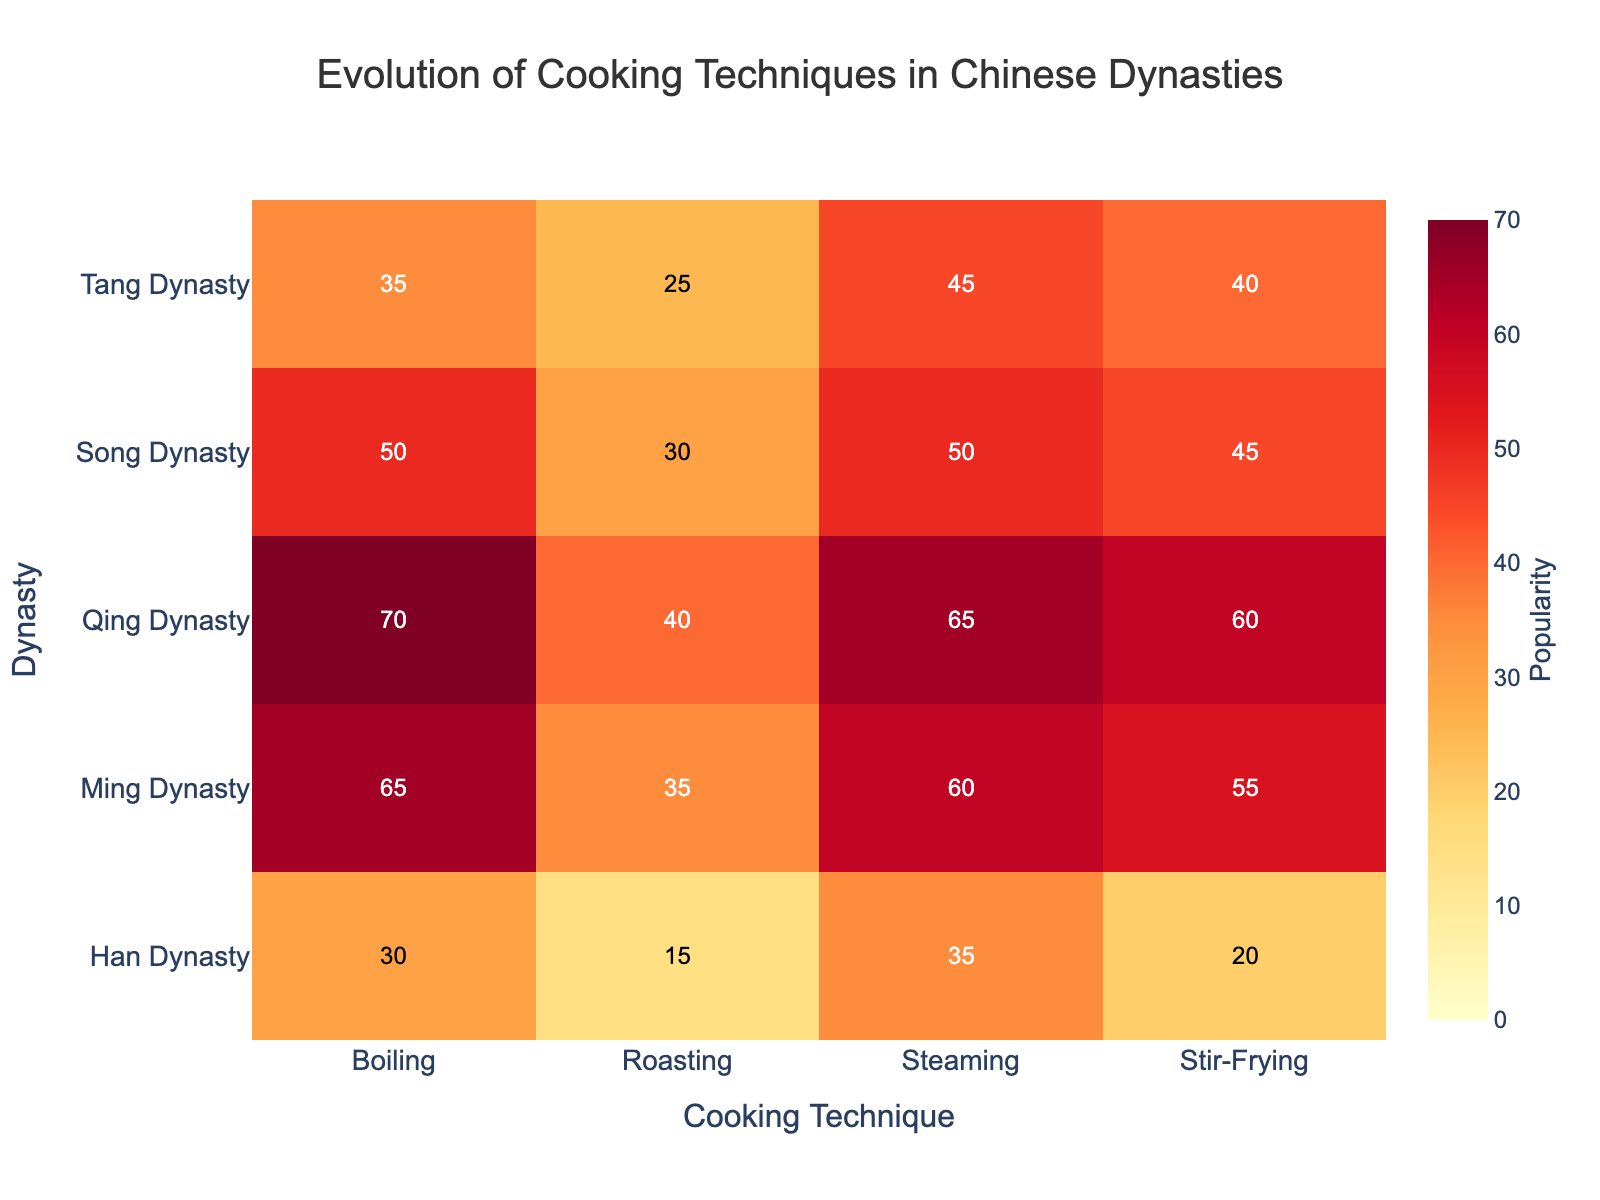Which dynasty shows the highest popularity for steaming? In the heatmap, look for the highest cell value in the "Steaming" column. The highest popularity value for steaming techniques is 65, which corresponds to the Qing Dynasty.
Answer: Qing Dynasty What was the least popular cooking technique during the Han Dynasty? From the heatmap, examine the row corresponding to the Han Dynasty and identify the cell with the lowest value. The roasting technique exhibits the lowest popularity value of 15.
Answer: Roasting How did the popularity of boiling evolve from the Han Dynasty to the Qing Dynasty? Trace the values in the "Boiling" column from the Han Dynasty to the Qing Dynasty: 30 (Han), 35 (Tang), 50 (Song), 65 (Ming), and 70 (Qing). The values increase progressively from 30 to 70.
Answer: Increased Which cooking technique saw the most significant increase in popularity from the Han Dynasty to the Qing Dynasty? Analyze each cooking technique's values over the dynasties. Identify the technique with the highest difference between the Qing and Han Dynasties: Stir-Frying (20 to 60, diff 40), Steaming (35 to 65, diff 30), Roasting (15 to 40, diff 25), Boiling (30 to 70, diff 40). Both Stir-Frying and Boiling increased by 40.
Answer: Stir-Frying and Boiling Between the Tang and Song Dynasties, which cooking technique had the most considerable increase in popularity? Compare the values for each technique between the Tang and Song Dynasties: Stir-Frying (40 to 45, diff 5), Steaming (45 to 50, diff 5), Roasting (25 to 30, diff 5), Boiling (35 to 50, diff 15). Boiling had the highest increase of 15.
Answer: Boiling What is the average popularity of roasting techniques across all dynasties? Sum the popularity values of the roasting technique across all dynasties (15+25+30+35+40 = 145) and divide by the number of dynasties (5). 145 / 5 = 29.
Answer: 29 Which cooking technique had the most consistent popularity (smallest range) across all dynasties? Calculate the range (max - min) for each technique: Stir-Frying (60 - 20 = 40), Steaming (65 - 35 = 30), Roasting (40 - 15 = 25), Boiling (70 - 30 = 40). Roasting had the smallest range of 25.
Answer: Roasting How many times did the popularity of steaming techniques exceed 50? Count the cells with a value greater than 50 in the "Steaming" column. There are two such instances (Qing - 65, Ming - 60).
Answer: 2 